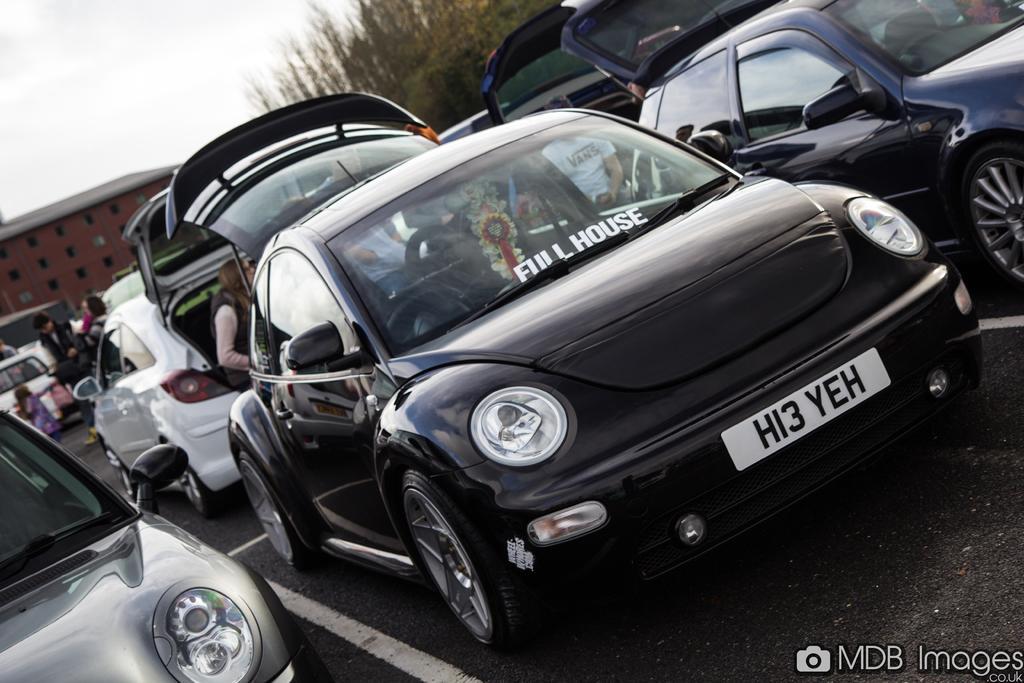In one or two sentences, can you explain what this image depicts? As we can see in the image there are black color cars, a person standing over here, buildings and trees. At the top there is sky. 